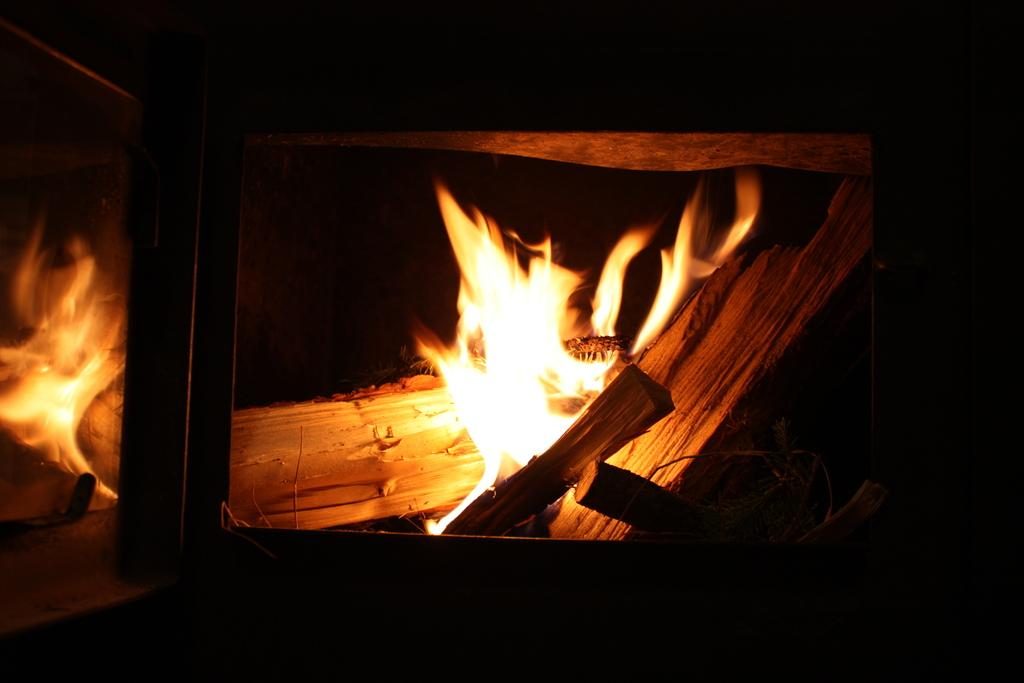What is the primary source of light in the image? There is fire in the image, which is a source of light. What is being burned to create the fire? There are wooden logs in the image, which are being burned to create the fire. What can be inferred about the setting of the image based on the background? The background of the image is black, which could suggest a dark or nighttime setting. What color is the eye of the person in the image? There is no person present in the image, and therefore no eye to observe. 